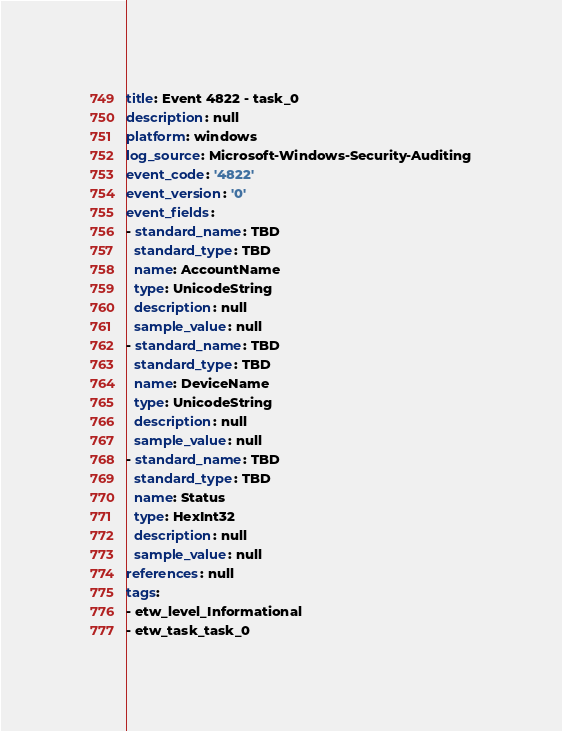<code> <loc_0><loc_0><loc_500><loc_500><_YAML_>title: Event 4822 - task_0
description: null
platform: windows
log_source: Microsoft-Windows-Security-Auditing
event_code: '4822'
event_version: '0'
event_fields:
- standard_name: TBD
  standard_type: TBD
  name: AccountName
  type: UnicodeString
  description: null
  sample_value: null
- standard_name: TBD
  standard_type: TBD
  name: DeviceName
  type: UnicodeString
  description: null
  sample_value: null
- standard_name: TBD
  standard_type: TBD
  name: Status
  type: HexInt32
  description: null
  sample_value: null
references: null
tags:
- etw_level_Informational
- etw_task_task_0
</code> 